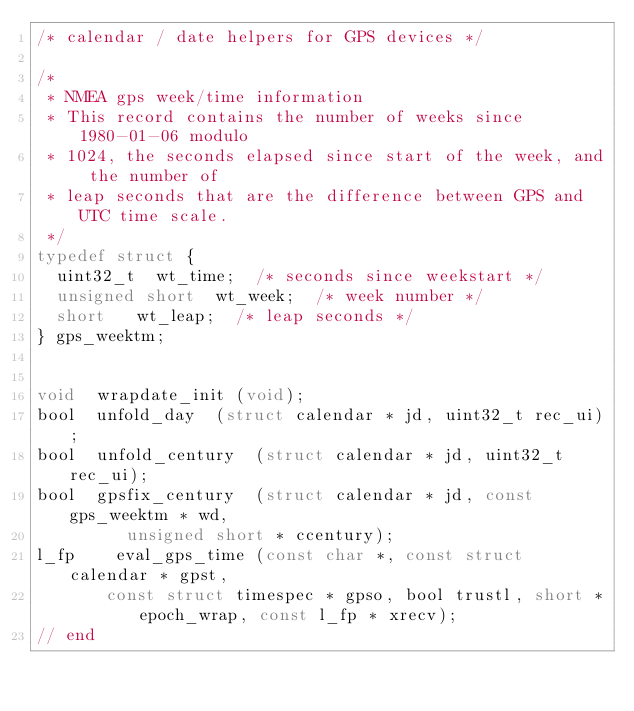Convert code to text. <code><loc_0><loc_0><loc_500><loc_500><_C_>/* calendar / date helpers for GPS devices */

/*
 * NMEA gps week/time information
 * This record contains the number of weeks since 1980-01-06 modulo
 * 1024, the seconds elapsed since start of the week, and the number of
 * leap seconds that are the difference between GPS and UTC time scale.
 */
typedef struct {
	uint32_t 	wt_time;	/* seconds since weekstart */
	unsigned short	wt_week;	/* week number */
	short		wt_leap;	/* leap seconds */
} gps_weektm;


void	wrapdate_init	(void);
bool	unfold_day	(struct calendar * jd, uint32_t rec_ui);
bool	unfold_century	(struct calendar * jd, uint32_t rec_ui);
bool	gpsfix_century	(struct calendar * jd, const gps_weektm * wd,
				 unsigned short * ccentury);
l_fp    eval_gps_time	(const char *, const struct calendar * gpst,
			 const struct timespec * gpso, bool trustl, short *epoch_wrap, const l_fp * xrecv);
// end
</code> 